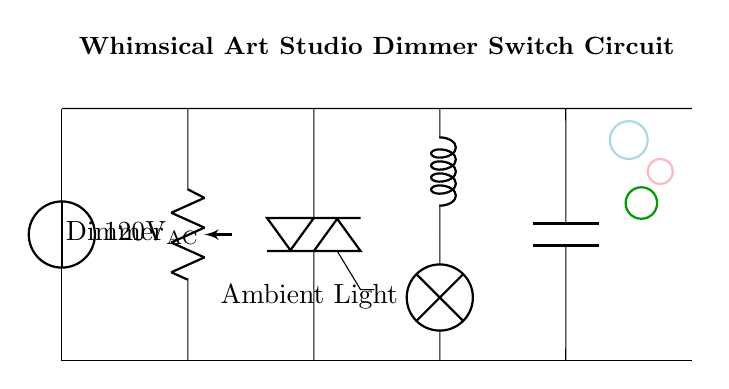What is the voltage of this circuit? The voltage source provides a potential of 120 volts, as indicated next to the voltage source symbol in the diagram.
Answer: 120 volts What type of component is used to adjust the brightness of the light? The component used to adjust the brightness is a dimmer switch, represented as a potentiometer in the circuit diagram.
Answer: Dimmer switch How many inductors are present in the circuit? There is only one inductor in the circuit, drawn between the TRIAC and the light bulb.
Answer: One What is the function of the TRIAC in this circuit? The TRIAC acts as a switch that controls the power supplied to the light bulb, allowing for dimming by varying the amount of current that flows through it.
Answer: Switching Which component is directly connected to the light bulb? The light bulb is directly connected to the inductor, as indicated by the connection lines from the inductor to the bulb in the circuit diagram.
Answer: Inductor What additional component is included for filtering in the circuit? The capacitor is included for filtering purposes, and it is connected in parallel after the inductor and before the light bulb.
Answer: Capacitor How does the dimmer switch affect the current flow? The dimmer switch alters the current flow by changing its resistance, thus adjusting the voltage across the light bulb and ultimately its brightness.
Answer: Alters current flow 